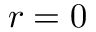Convert formula to latex. <formula><loc_0><loc_0><loc_500><loc_500>r = 0</formula> 